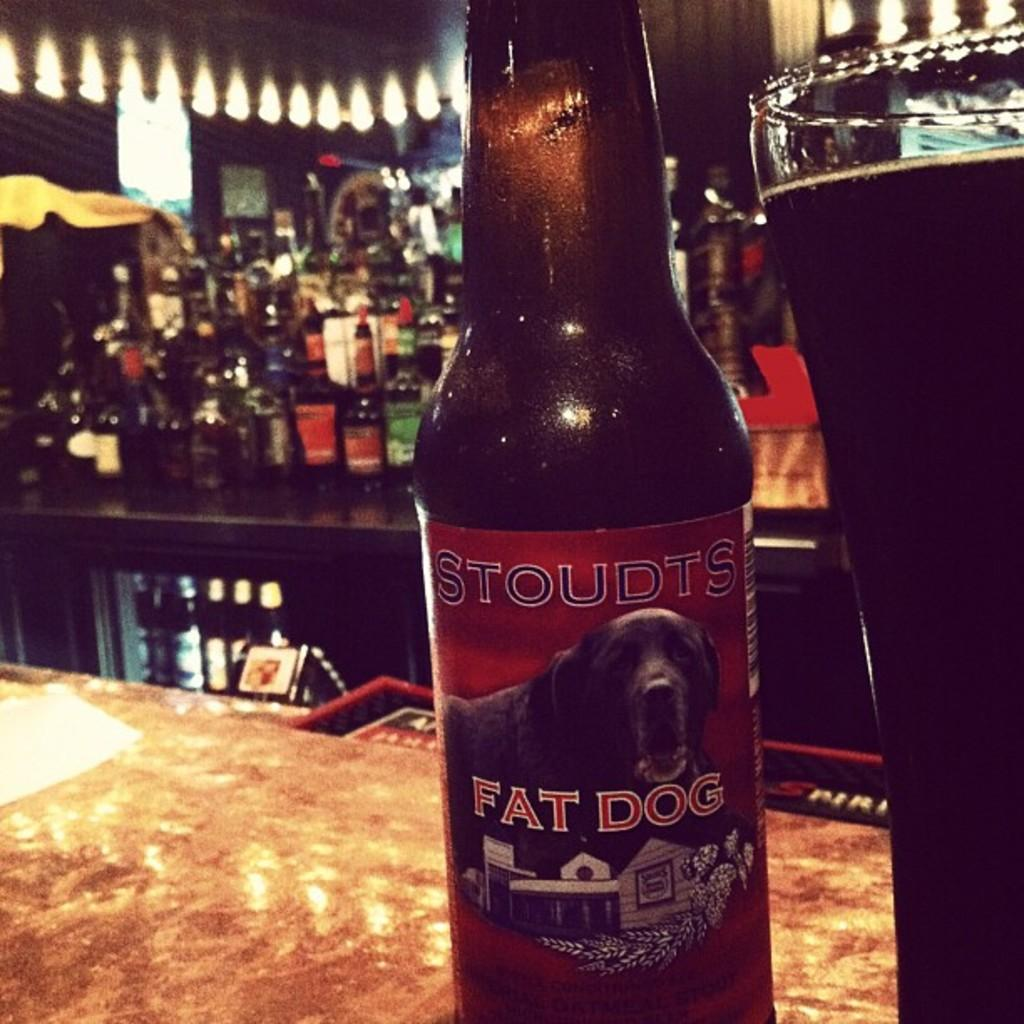Provide a one-sentence caption for the provided image. A bottle of Stoudts Fat Dog beer is on a bar counter. 